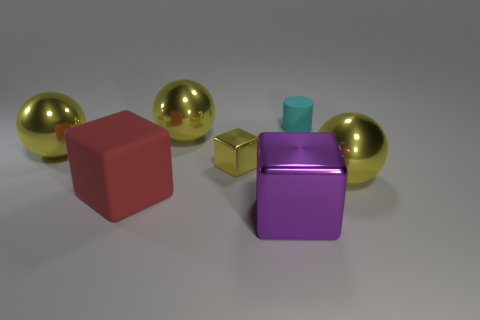Subtract all yellow spheres. How many were subtracted if there are1yellow spheres left? 2 Add 2 cyan matte cylinders. How many objects exist? 9 Subtract all cylinders. How many objects are left? 6 Add 1 big purple metal cubes. How many big purple metal cubes are left? 2 Add 2 big rubber cylinders. How many big rubber cylinders exist? 2 Subtract 0 purple spheres. How many objects are left? 7 Subtract all big cyan metal balls. Subtract all big matte objects. How many objects are left? 6 